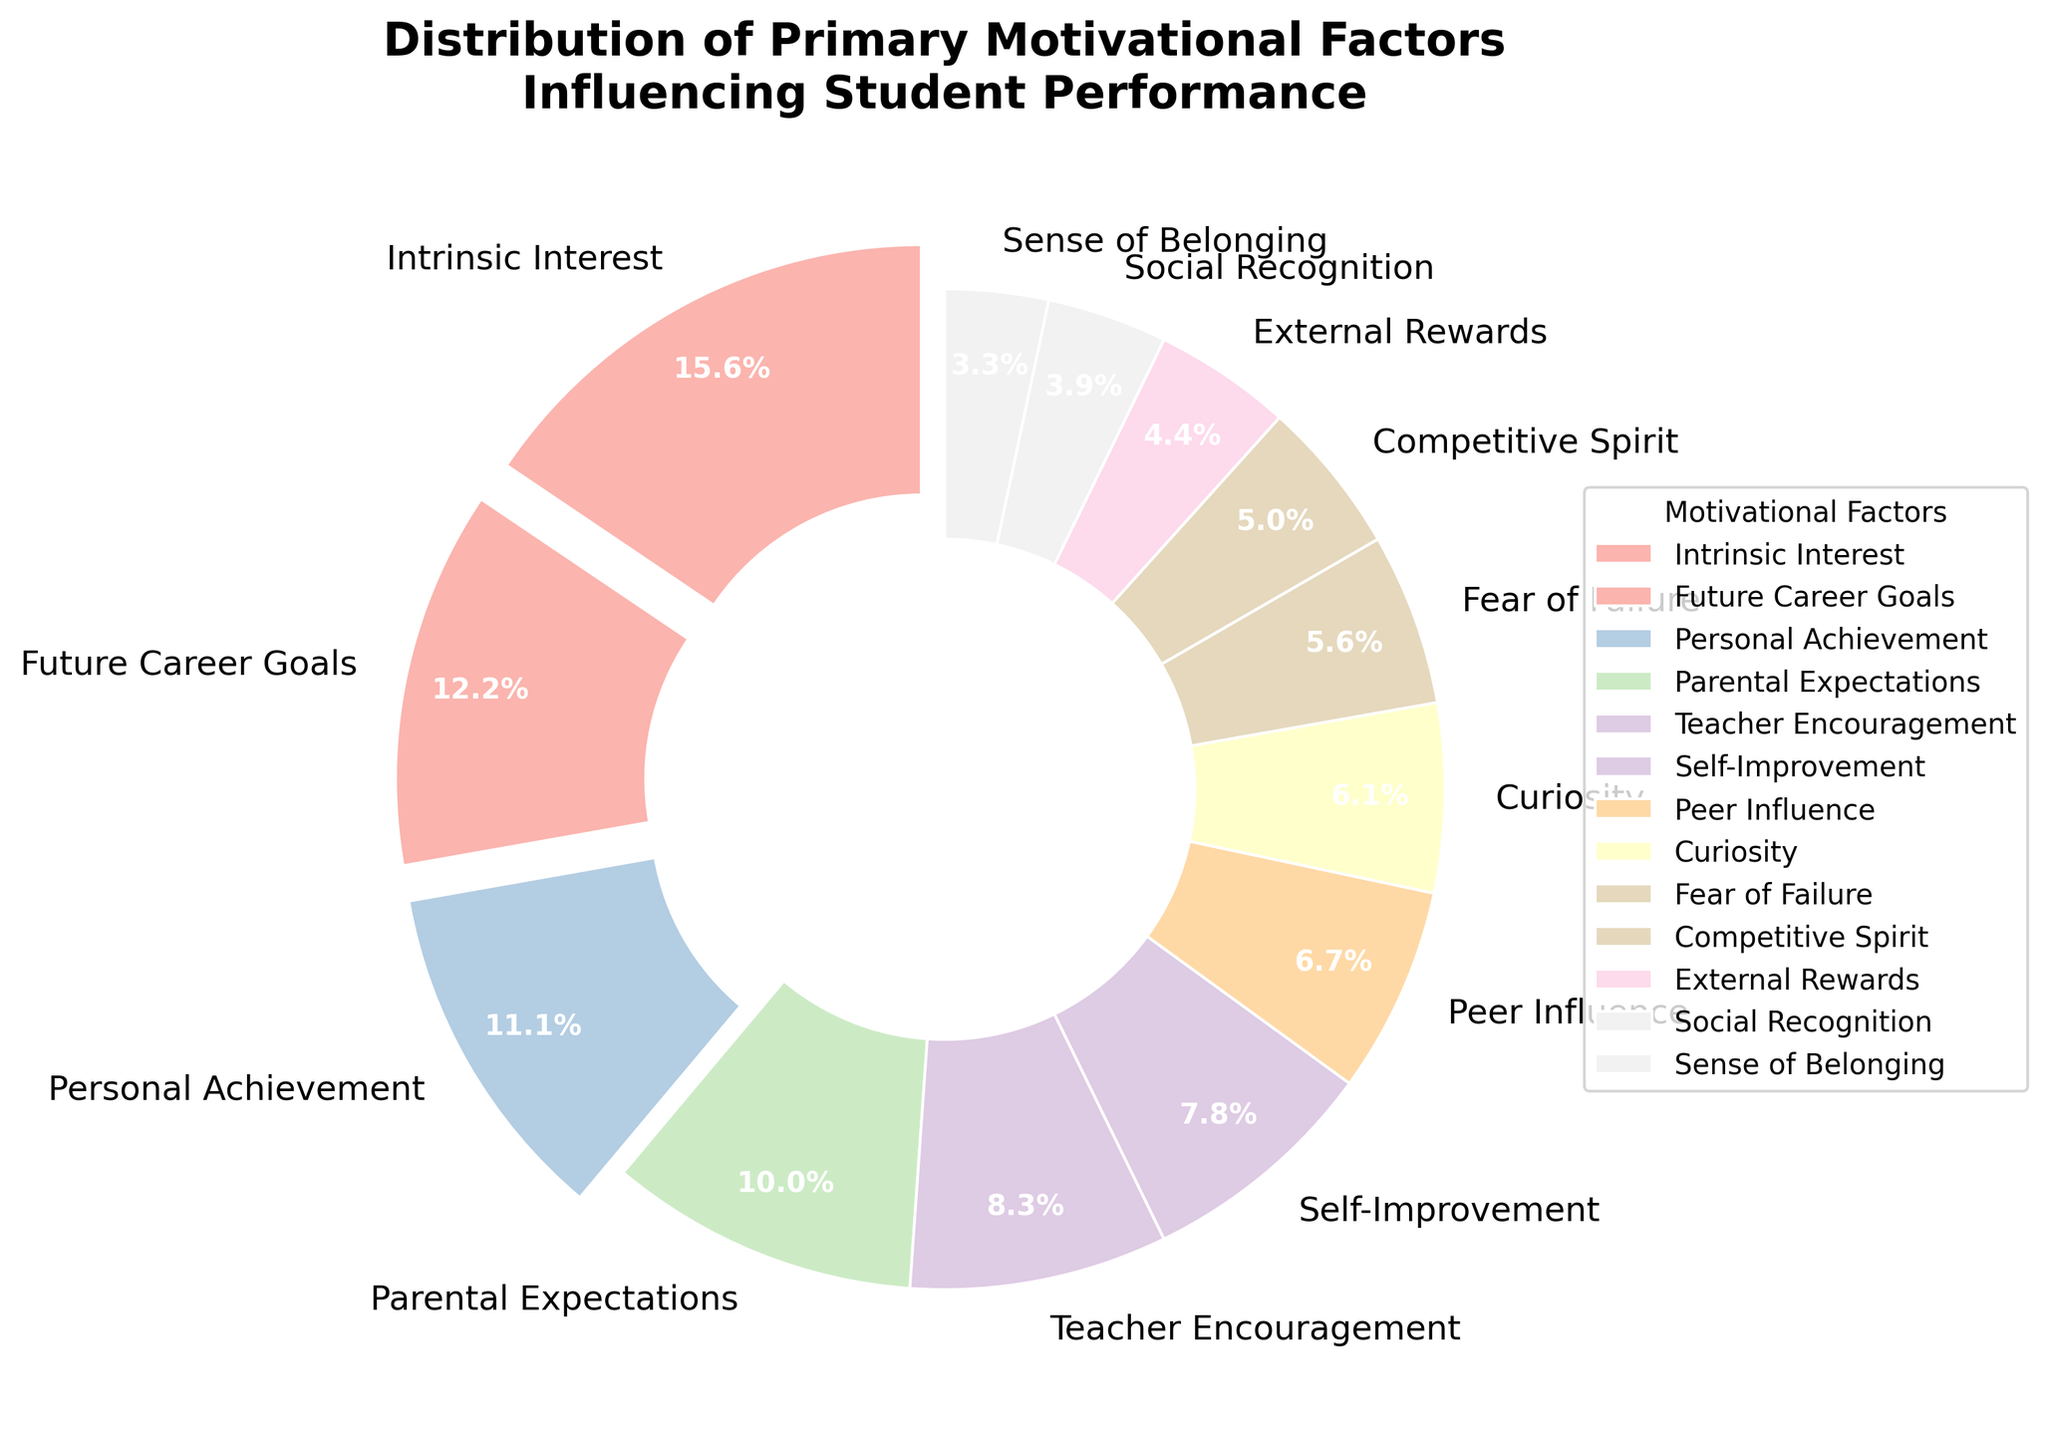What is the largest motivational factor influencing student performance? The largest segment in the pie chart is “Intrinsic Interest,” which occupies the most prominent area and is visually distinct with its standout size.
Answer: Intrinsic Interest What is the combined percentage of "Fear of Failure" and "Self-Improvement"? The segment for "Fear of Failure" is 10%, and the segment for "Self-Improvement" is 14%. Adding these percentages together, we get 10% + 14% = 24%.
Answer: 24% Which motivational factors occupy less than 10% each? From the pie chart, the segments labeled "External Rewards," "Social Recognition," "Sense of Belonging," and "Competitive Spirit" each have percentages below 10%. Specifically, "External Rewards" has 8%, "Social Recognition" has 7%, "Sense of Belonging" has 6%, and "Competitive Spirit" has 9%.
Answer: External Rewards, Social Recognition, Sense of Belonging, Competitive Spirit How does the percentage of "Personal Achievement" compare to "Future Career Goals"? The pie chart shows that "Personal Achievement" accounts for 20% while "Future Career Goals" holds 22%, which indicates that "Future Career Goals" is slightly higher by 2%.
Answer: Future Career Goals is 2% higher What is the average percentage of the top three motivational factors? The top three segments are "Intrinsic Interest" (28%), "Future Career Goals" (22%), and "Personal Achievement" (20%). The average is calculated by summing these percentages and dividing by 3: (28% + 22% + 20%) / 3 = 70% / 3 ≈ 23.33%.
Answer: 23.33% What is the difference in percentage between the highest and lowest motivational factor? The highest motivational factor is "Intrinsic Interest" at 28%, and the lowest is "Sense of Belonging" at 6%. The difference is calculated by subtracting the smallest percentage from the largest: 28% - 6% = 22%.
Answer: 22% Which motivational factor has a similar percentage to "Curiosity"? "Curiosity" has a percentage of 11%. Looking at the chart, "Fear of Failure" is close with 10%.
Answer: Fear of Failure Are there any motivational factors with a difference of 3% or less? Observing the pie chart, the pairs: "Intrinsic Interest" (28%) and "Future Career Goals" (22%), "Curiosity" (11%) and "Fear of Failure" (10%), and "Parental Expectations" (18%) and "Teacher Encouragement" (15%) have differences of 3% or less.
Answer: Intrinsic Interest & Future Career Goals, Curiosity & Fear of Failure, Parental Expectations & Teacher Encouragement How many motivational factors have a percentage of 15% or higher? The chart shows six motivational factors with percentages of 15% or higher: "Intrinsic Interest" (28%), "Future Career Goals" (22%), "Personal Achievement" (20%), "Parental Expectations" (18%), "Teacher Encouragement" (15%), and "Self-Improvement" (14%). However, "Self-Improvement" is less than 15%, so the correct count is five.
Answer: 5 